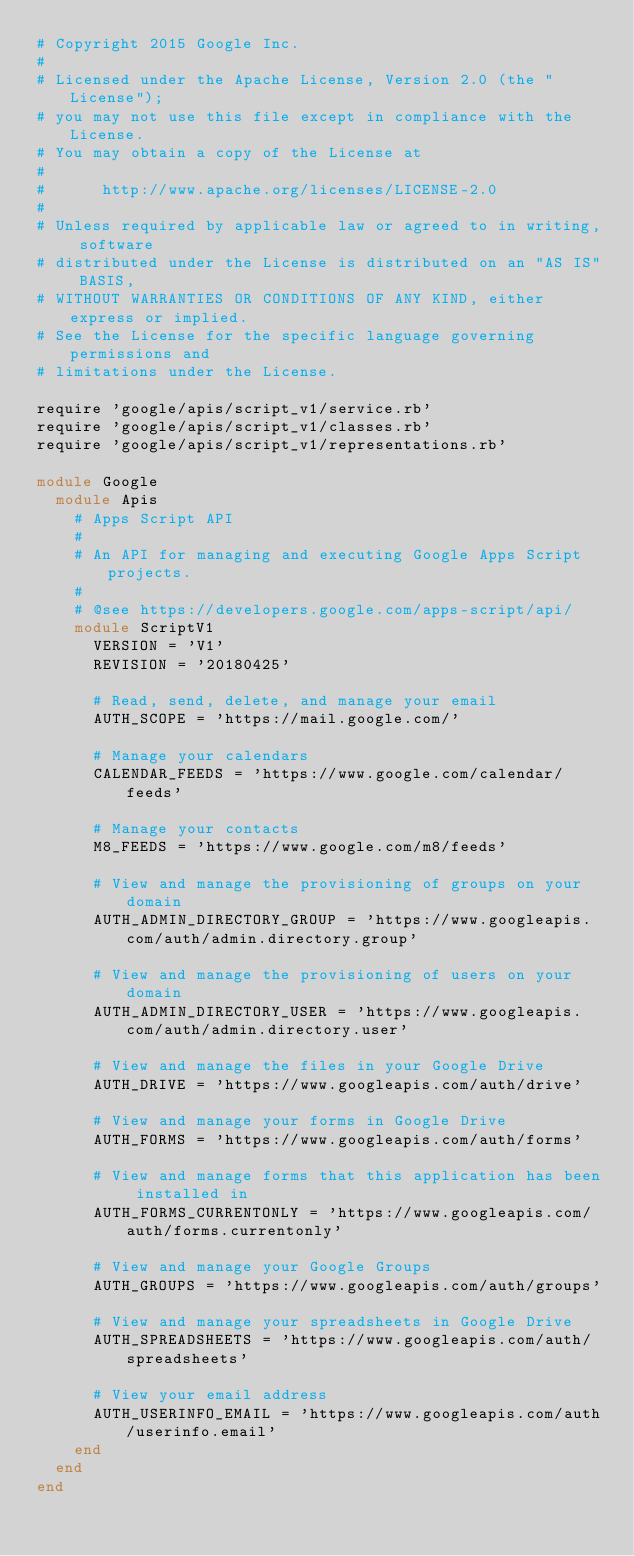Convert code to text. <code><loc_0><loc_0><loc_500><loc_500><_Ruby_># Copyright 2015 Google Inc.
#
# Licensed under the Apache License, Version 2.0 (the "License");
# you may not use this file except in compliance with the License.
# You may obtain a copy of the License at
#
#      http://www.apache.org/licenses/LICENSE-2.0
#
# Unless required by applicable law or agreed to in writing, software
# distributed under the License is distributed on an "AS IS" BASIS,
# WITHOUT WARRANTIES OR CONDITIONS OF ANY KIND, either express or implied.
# See the License for the specific language governing permissions and
# limitations under the License.

require 'google/apis/script_v1/service.rb'
require 'google/apis/script_v1/classes.rb'
require 'google/apis/script_v1/representations.rb'

module Google
  module Apis
    # Apps Script API
    #
    # An API for managing and executing Google Apps Script projects.
    #
    # @see https://developers.google.com/apps-script/api/
    module ScriptV1
      VERSION = 'V1'
      REVISION = '20180425'

      # Read, send, delete, and manage your email
      AUTH_SCOPE = 'https://mail.google.com/'

      # Manage your calendars
      CALENDAR_FEEDS = 'https://www.google.com/calendar/feeds'

      # Manage your contacts
      M8_FEEDS = 'https://www.google.com/m8/feeds'

      # View and manage the provisioning of groups on your domain
      AUTH_ADMIN_DIRECTORY_GROUP = 'https://www.googleapis.com/auth/admin.directory.group'

      # View and manage the provisioning of users on your domain
      AUTH_ADMIN_DIRECTORY_USER = 'https://www.googleapis.com/auth/admin.directory.user'

      # View and manage the files in your Google Drive
      AUTH_DRIVE = 'https://www.googleapis.com/auth/drive'

      # View and manage your forms in Google Drive
      AUTH_FORMS = 'https://www.googleapis.com/auth/forms'

      # View and manage forms that this application has been installed in
      AUTH_FORMS_CURRENTONLY = 'https://www.googleapis.com/auth/forms.currentonly'

      # View and manage your Google Groups
      AUTH_GROUPS = 'https://www.googleapis.com/auth/groups'

      # View and manage your spreadsheets in Google Drive
      AUTH_SPREADSHEETS = 'https://www.googleapis.com/auth/spreadsheets'

      # View your email address
      AUTH_USERINFO_EMAIL = 'https://www.googleapis.com/auth/userinfo.email'
    end
  end
end
</code> 